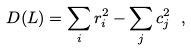<formula> <loc_0><loc_0><loc_500><loc_500>D ( L ) = \sum _ { i } r _ { i } ^ { 2 } - \sum _ { j } c _ { j } ^ { 2 } \ ,</formula> 